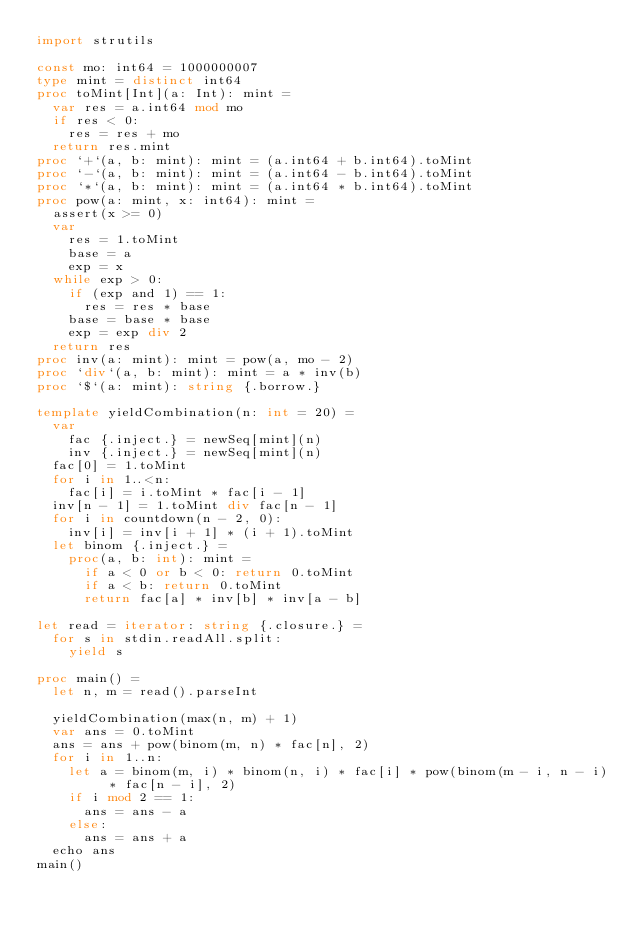<code> <loc_0><loc_0><loc_500><loc_500><_Nim_>import strutils

const mo: int64 = 1000000007
type mint = distinct int64
proc toMint[Int](a: Int): mint =
  var res = a.int64 mod mo
  if res < 0:
    res = res + mo
  return res.mint
proc `+`(a, b: mint): mint = (a.int64 + b.int64).toMint
proc `-`(a, b: mint): mint = (a.int64 - b.int64).toMint
proc `*`(a, b: mint): mint = (a.int64 * b.int64).toMint
proc pow(a: mint, x: int64): mint =
  assert(x >= 0)
  var
    res = 1.toMint
    base = a
    exp = x
  while exp > 0:
    if (exp and 1) == 1:
      res = res * base
    base = base * base
    exp = exp div 2
  return res
proc inv(a: mint): mint = pow(a, mo - 2)
proc `div`(a, b: mint): mint = a * inv(b)
proc `$`(a: mint): string {.borrow.}

template yieldCombination(n: int = 20) =
  var
    fac {.inject.} = newSeq[mint](n)
    inv {.inject.} = newSeq[mint](n)
  fac[0] = 1.toMint
  for i in 1..<n:
    fac[i] = i.toMint * fac[i - 1]
  inv[n - 1] = 1.toMint div fac[n - 1]
  for i in countdown(n - 2, 0):
    inv[i] = inv[i + 1] * (i + 1).toMint
  let binom {.inject.} =
    proc(a, b: int): mint =
      if a < 0 or b < 0: return 0.toMint
      if a < b: return 0.toMint
      return fac[a] * inv[b] * inv[a - b]

let read = iterator: string {.closure.} =
  for s in stdin.readAll.split:
    yield s

proc main() =
  let n, m = read().parseInt

  yieldCombination(max(n, m) + 1)
  var ans = 0.toMint
  ans = ans + pow(binom(m, n) * fac[n], 2)
  for i in 1..n:
    let a = binom(m, i) * binom(n, i) * fac[i] * pow(binom(m - i, n - i) * fac[n - i], 2)
    if i mod 2 == 1:
      ans = ans - a
    else:
      ans = ans + a
  echo ans
main()
</code> 